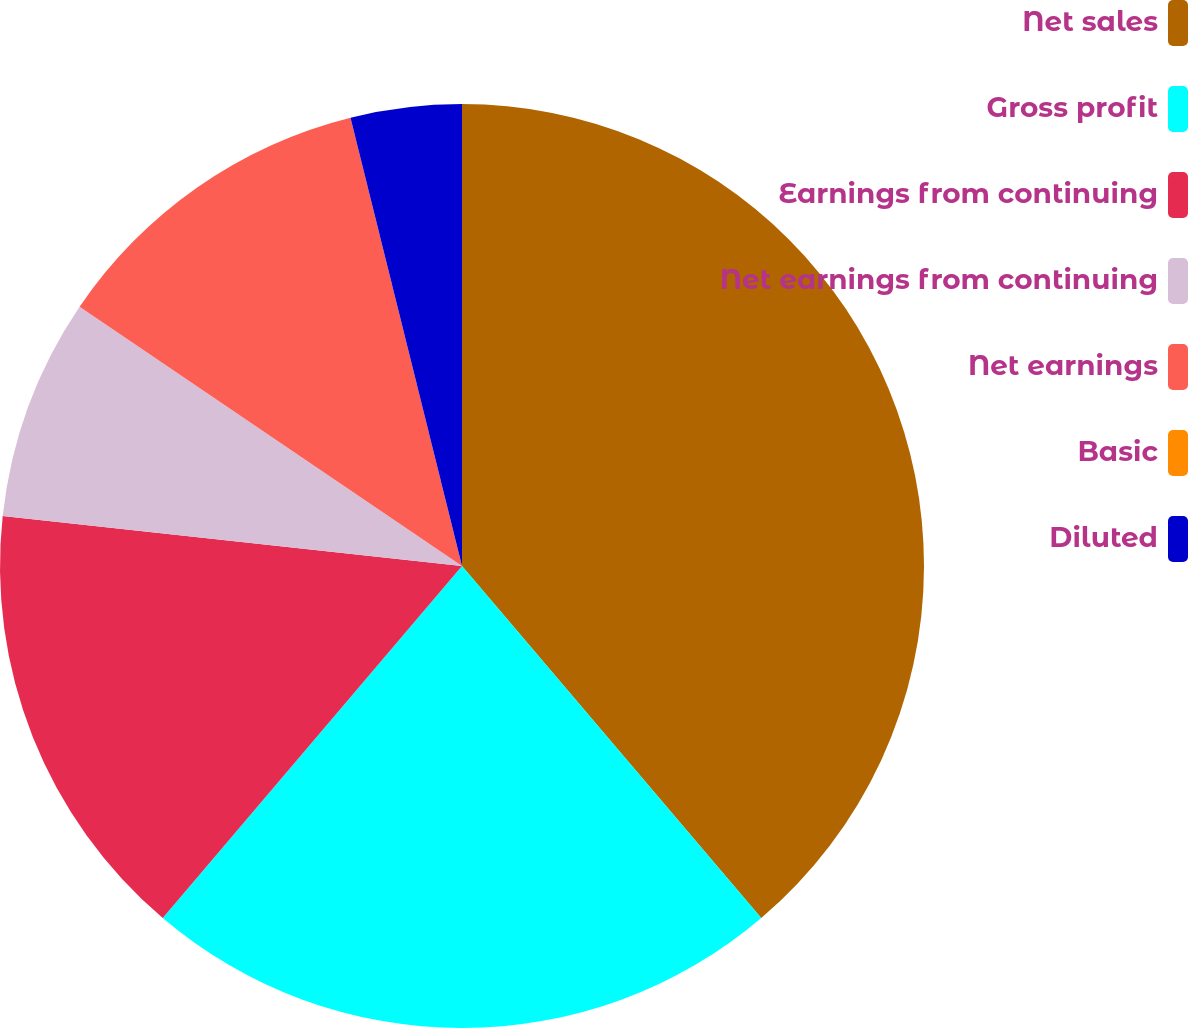Convert chart to OTSL. <chart><loc_0><loc_0><loc_500><loc_500><pie_chart><fcel>Net sales<fcel>Gross profit<fcel>Earnings from continuing<fcel>Net earnings from continuing<fcel>Net earnings<fcel>Basic<fcel>Diluted<nl><fcel>38.79%<fcel>22.43%<fcel>15.51%<fcel>7.76%<fcel>11.64%<fcel>0.0%<fcel>3.88%<nl></chart> 